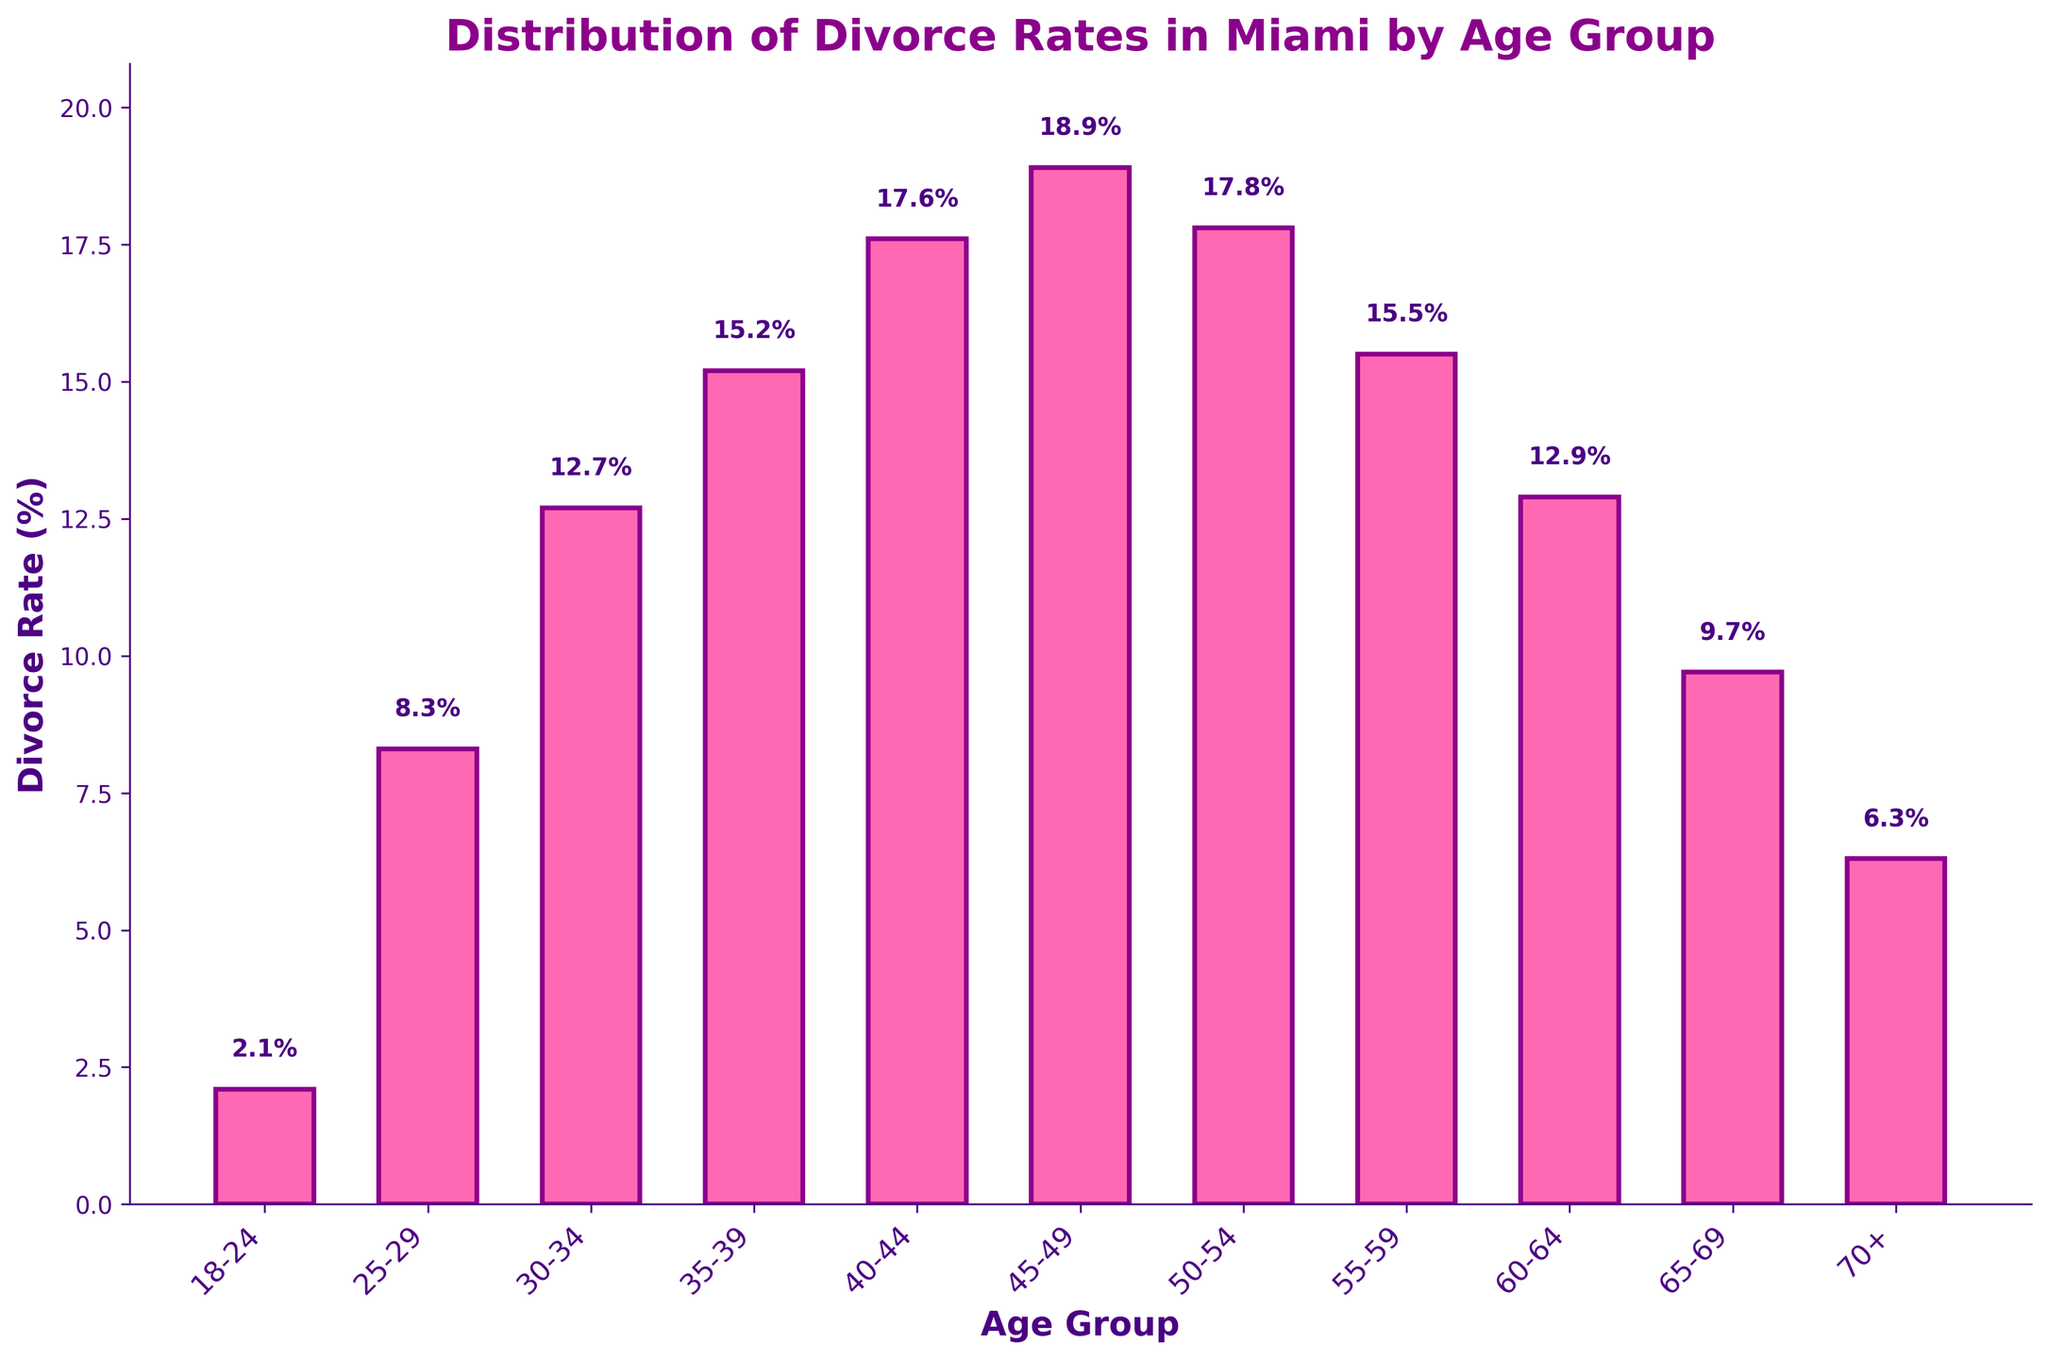Which age group has the highest divorce rate? Look at the bars and find the tallest one. The tallest bar represents the 45-49 age group with a divorce rate of 18.9%.
Answer: 45-49 Which age group has the lowest divorce rate? Look at the bars and find the shortest one. The shortest bar represents the 18-24 age group with a divorce rate of 2.1%.
Answer: 18-24 What's the difference in divorce rates between the 40-44 and 30-34 age groups? Subtract the divorce rate of the 30-34 age group (12.7%) from that of the 40-44 age group (17.6%). The difference is 17.6% - 12.7% = 4.9%.
Answer: 4.9% What is the average divorce rate for the age groups 50-54, 55-59, and 60-64? Add the divorce rates of the age groups 50-54 (17.8%), 55-59 (15.5%), and 60-64 (12.9%), then divide by 3. (17.8 + 15.5 + 12.9) / 3 = 15.4%.
Answer: 15.4% Which age groups have a divorce rate greater than 15%? Identify the bars that reach higher than the 15% mark. The age groups 35-39, 40-44, 45-49, and 55-59 all have divorce rates over 15%.
Answer: 35-39, 40-44, 45-49, 55-59 Is the divorce rate higher for the 35-39 age group or the 60-64 age group? Compare the heights of the bars for the 35-39 and 60-64 age groups. The 35-39 age group has a higher divorce rate (15.2%) compared to 60-64 (12.9%).
Answer: 35-39 What is the median divorce rate among all the age groups? List all the divorce rates and find the middle value. Arrange the rates: 2.1, 6.3, 8.3, 9.7, 12.7, 12.9, 15.2, 15.5, 17.6, 17.8, 18.9. The median value is the sixth number when listed in order, which is 12.9%.
Answer: 12.9% How much greater is the divorce rate for the 45-49 age group compared to the 18-24 age group? Subtract the divorce rate of the 18-24 age group (2.1%) from the 45-49 age group (18.9%). The difference is 18.9% - 2.1% = 16.8%.
Answer: 16.8% Which age group(s) have divorce rates closest to 10%? Look for bars closest to the 10% mark. The 65-69 (9.7%) and 25-29 (8.3%) age groups have divorce rates closest to 10%.
Answer: 65-69, 25-29 